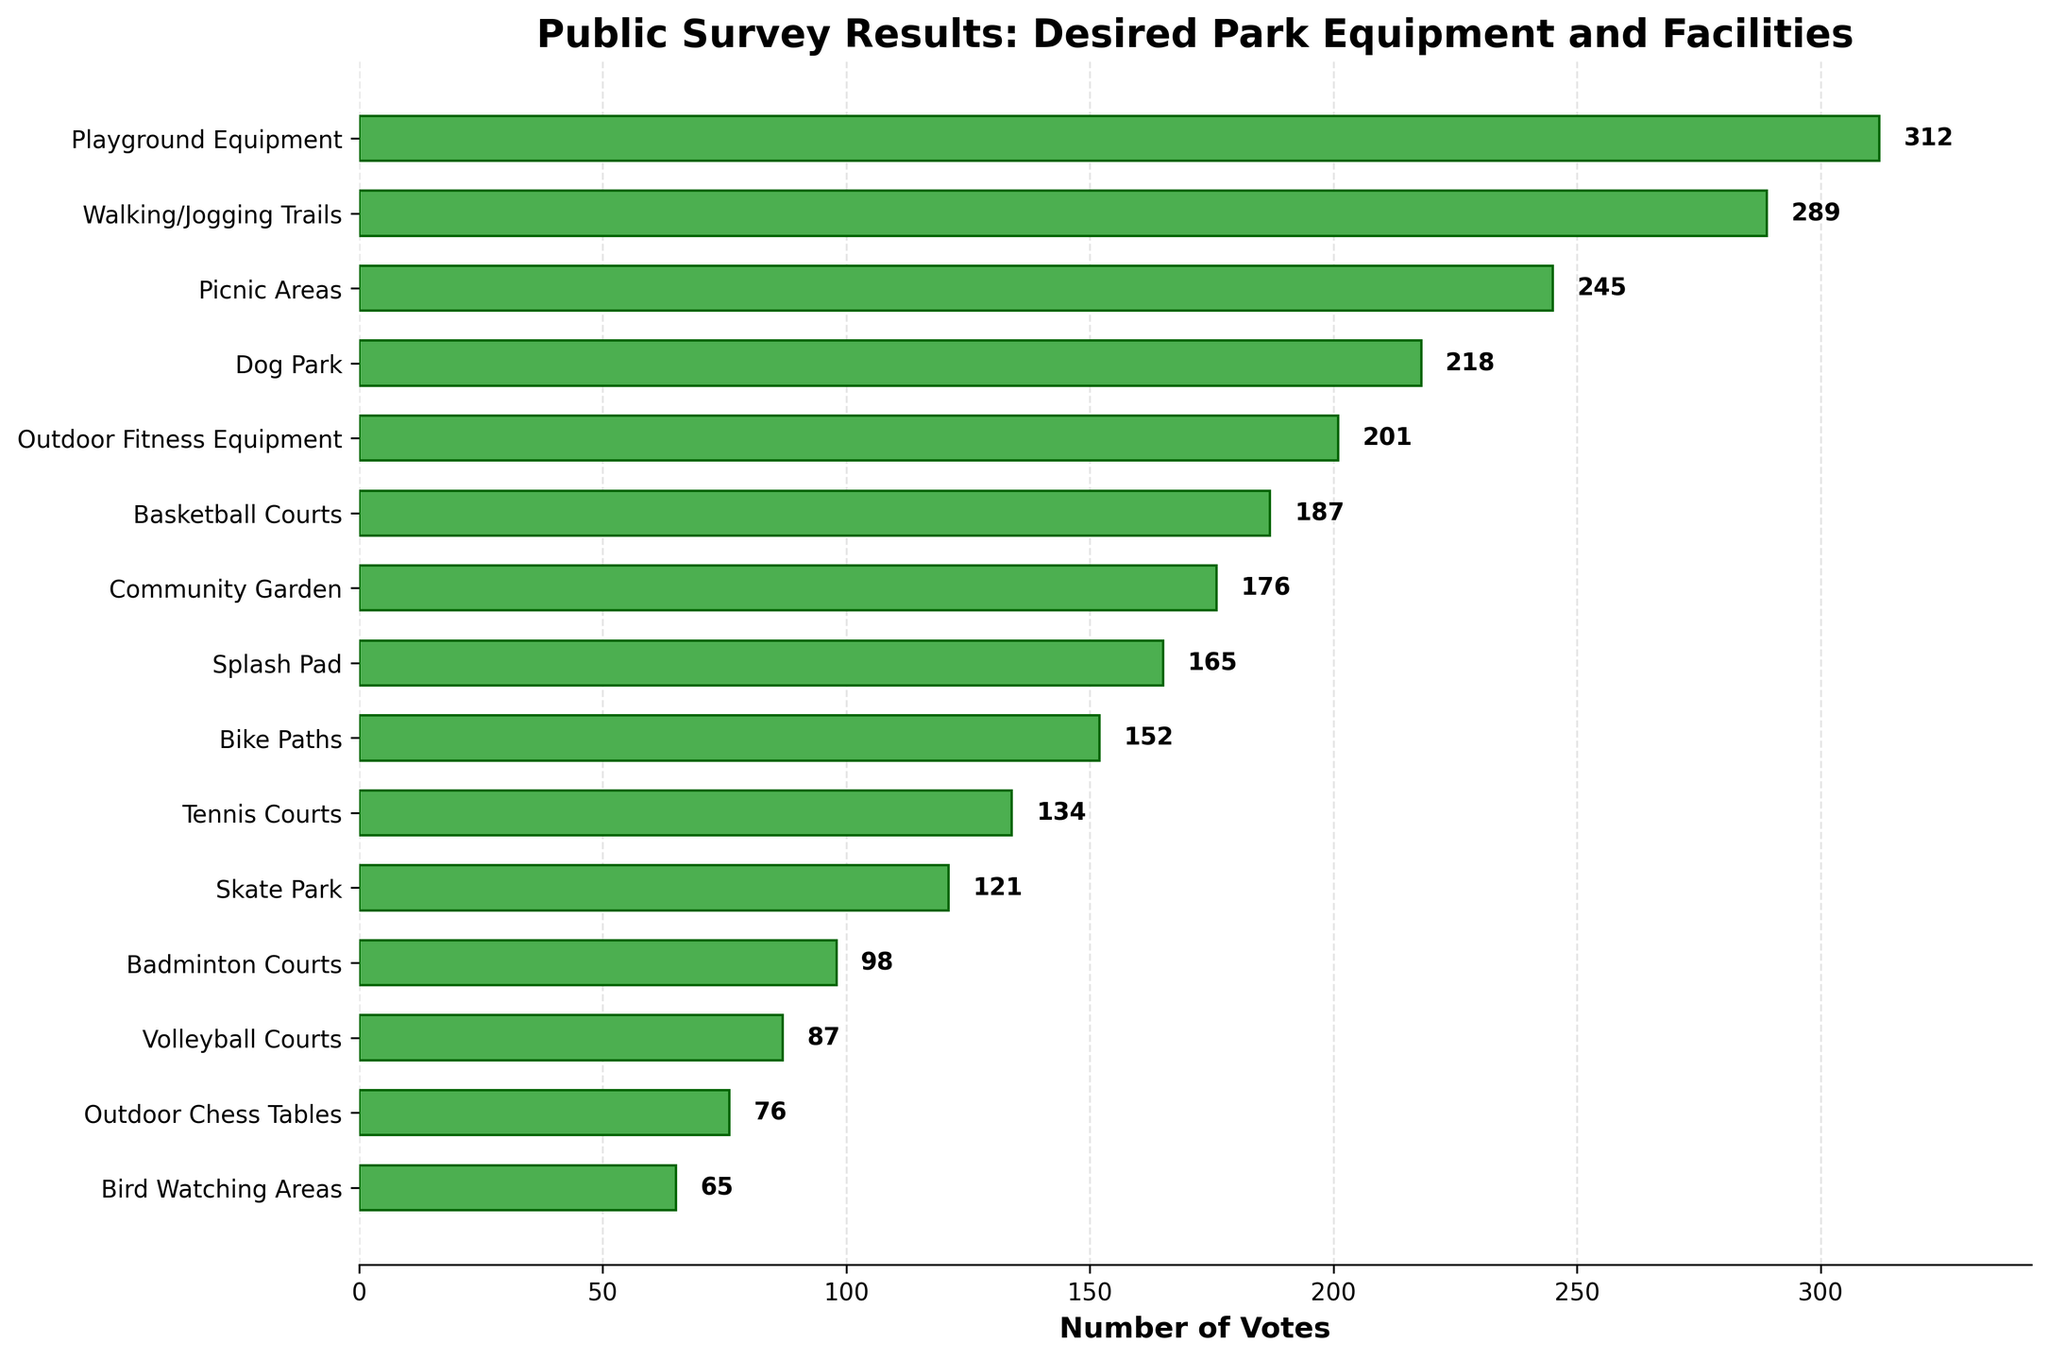Which equipment/facility received the highest number of votes? The playground equipment bar is the longest and has the highest value of 312 votes.
Answer: Playground Equipment Which equipment received fewer votes, Basketball Courts or Tennis Courts? Compare the lengths of the bars; Basketball Courts has 187 votes, and Tennis Courts has 134 votes. Tennis Courts received fewer votes.
Answer: Tennis Courts By how many votes did Walking/Jogging Trails rank second compared to Picnic Areas? Walking/Jogging Trails received 289 votes, Picnic Areas received 245 votes. The difference is 289 - 245 = 44 votes.
Answer: 44 Are the votes for Outdoor Fitness Equipment greater or lesser than those for Dog Park? Outdoor Fitness Equipment received 201 votes, and Dog Park received 218 votes. 201 is less than 218.
Answer: Lesser What is the total number of votes for the top three rated facilities? Summing the votes of the top three facilities: 312 (Playground Equipment) + 289 (Walking/Jogging Trails) + 245 (Picnic Areas) = 846 votes.
Answer: 846 Which facility received the least number of votes and how many? The bar for Bird Watching Areas is the shortest with 65 votes.
Answer: Bird Watching Areas, 65 How many more votes did Skate Park receive compared to Badminton Courts? Compare the votes, Skate Park has 121 votes, Badminton Courts has 98 votes. The difference is 121 - 98 = 23 votes.
Answer: 23 List the facilities that received between 150 and 200 votes. Looking at the bars, those facilities are Outdoor Fitness Equipment (201 votes), Basketball Courts (187 votes), Community Garden (176 votes), and Splash Pad (165 votes).
Answer: Outdoor Fitness Equipment, Basketball Courts, Community Garden, Splash Pad What's the average number of votes for Splash Pad, Bike Paths, and Tennis Courts? Adding their votes: 165 + 152 + 134 = 451, then dividing by the number of facilities: 451 / 3 = 150.33
Answer: 150.33 How does the number of votes for Volleyball Courts compare to Outdoor Chess Tables? Volleyball Courts received 87 votes, and Outdoor Chess Tables received 76 votes. Comparing the two, 87 is greater than 76.
Answer: Greater 